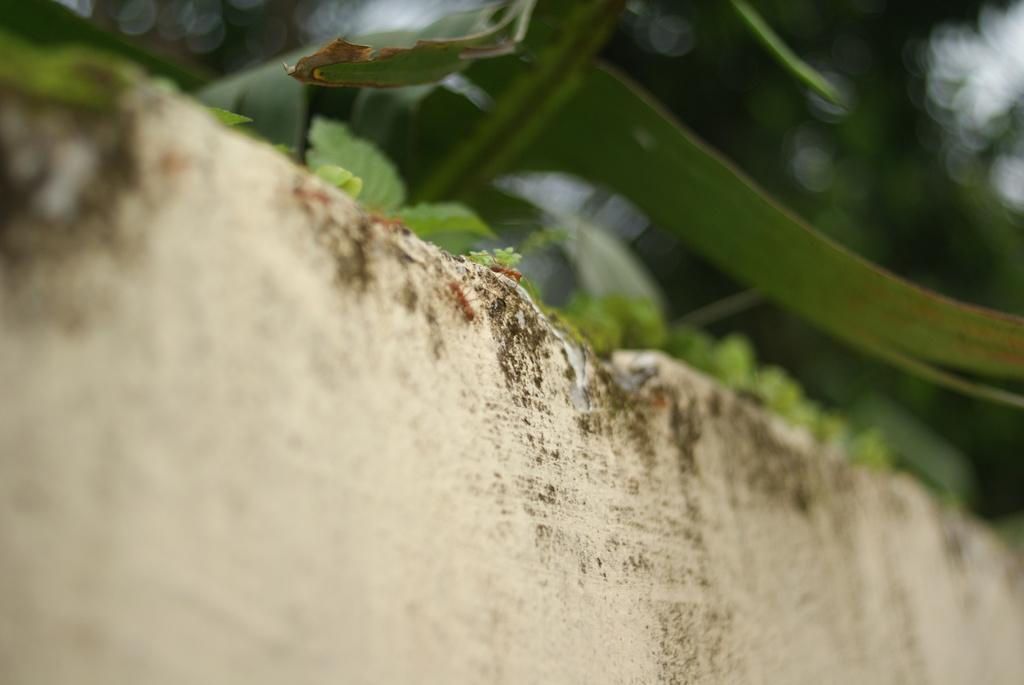What is located at the bottom of the image? There is a wall at the bottom of the image. What can be seen on the wall? There are ants on the wall. What type of vegetation is visible at the top of the image? There are leaves visible at the top of the image. Can you hear the whistle of the crook in the image? There is no crook or whistle present in the image. 